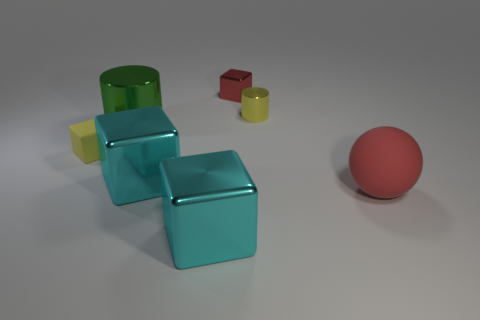What color is the big metal block behind the matte thing right of the yellow thing on the left side of the red cube?
Ensure brevity in your answer.  Cyan. There is a big thing that is in front of the red ball; is it the same shape as the tiny matte object?
Your answer should be very brief. Yes. The ball that is the same size as the green metallic thing is what color?
Give a very brief answer. Red. How many brown spheres are there?
Offer a very short reply. 0. Does the yellow object that is in front of the yellow shiny cylinder have the same material as the yellow cylinder?
Offer a terse response. No. There is a thing that is both to the right of the tiny shiny block and in front of the green shiny object; what is its material?
Your answer should be compact. Rubber. There is a rubber sphere that is the same color as the small metal block; what is its size?
Offer a very short reply. Large. There is a small cube in front of the shiny block behind the large green cylinder; what is its material?
Make the answer very short. Rubber. There is a metal object that is behind the tiny metallic object that is in front of the tiny block right of the rubber block; what is its size?
Keep it short and to the point. Small. What number of green objects have the same material as the red block?
Make the answer very short. 1. 